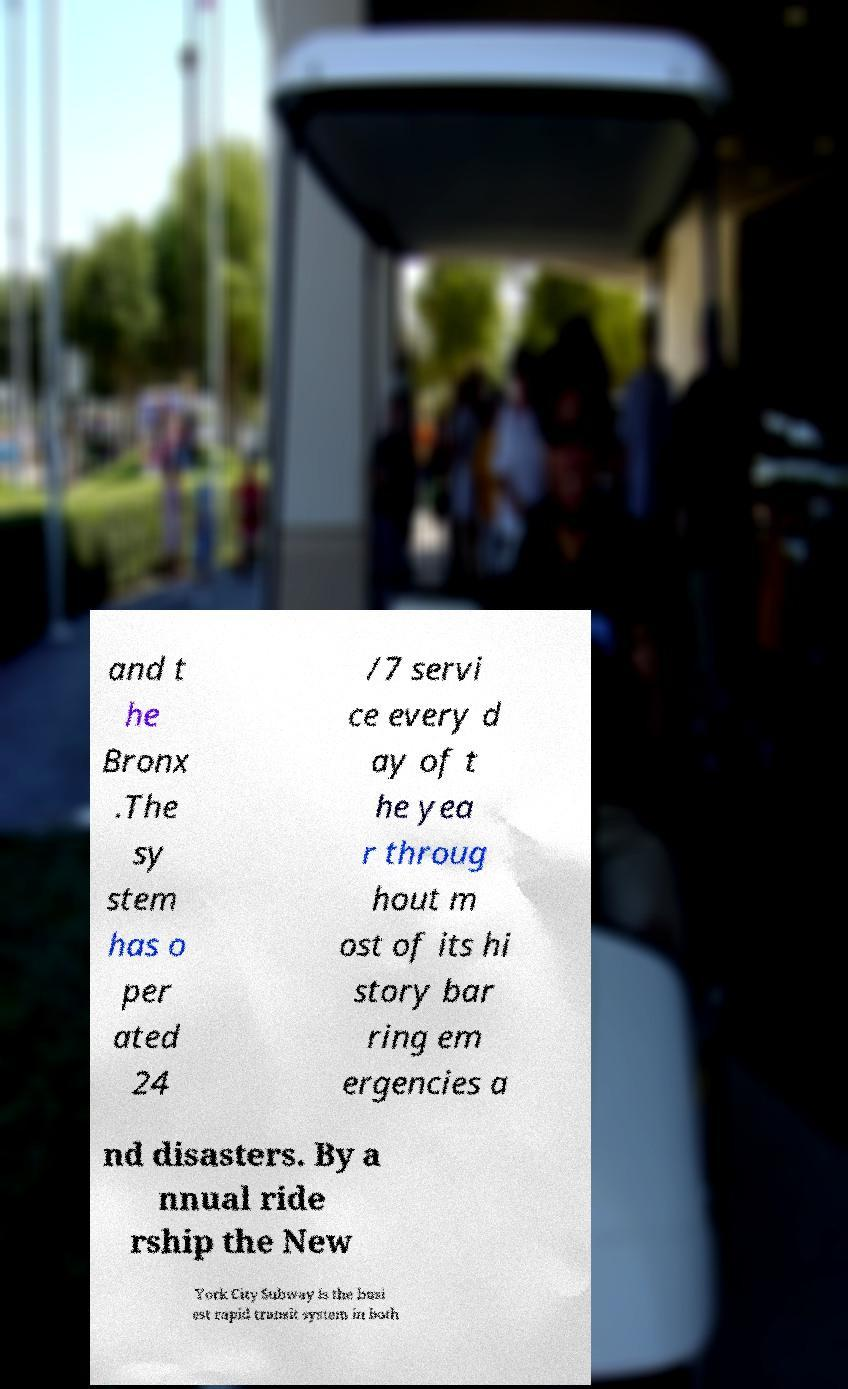Can you accurately transcribe the text from the provided image for me? and t he Bronx .The sy stem has o per ated 24 /7 servi ce every d ay of t he yea r throug hout m ost of its hi story bar ring em ergencies a nd disasters. By a nnual ride rship the New York City Subway is the busi est rapid transit system in both 